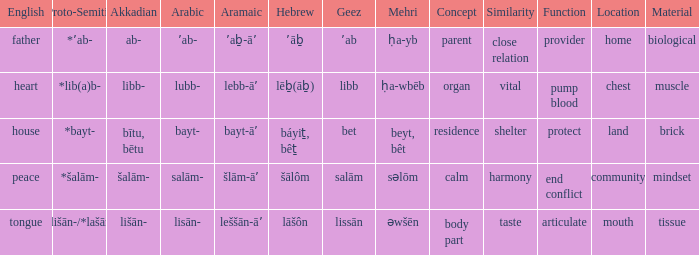If the geez is libb, what is the akkadian? Libb-. 